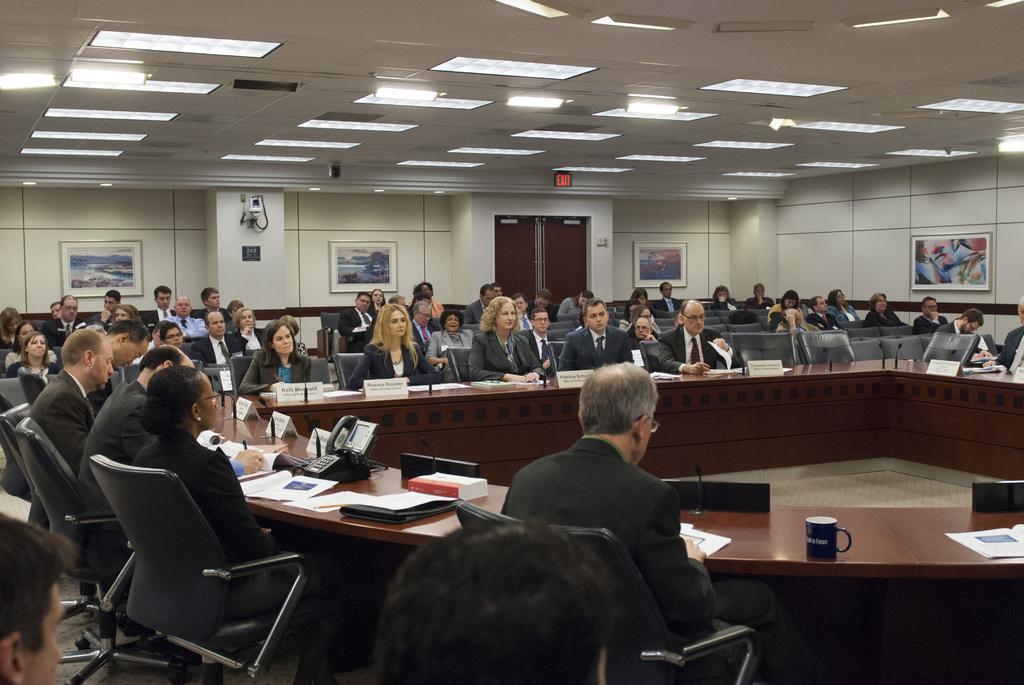In one or two sentences, can you explain what this image depicts? In this image in front there are people sitting on the chairs. In front of them there is a table. On top of the table there are name boards. There are files, papers, cups. There is a landline phone. Behind them there are few other people sitting on the chairs. In the background of the image there are photo frames on the wall. In the center of the image there is a door. On top of the image there are lights. 